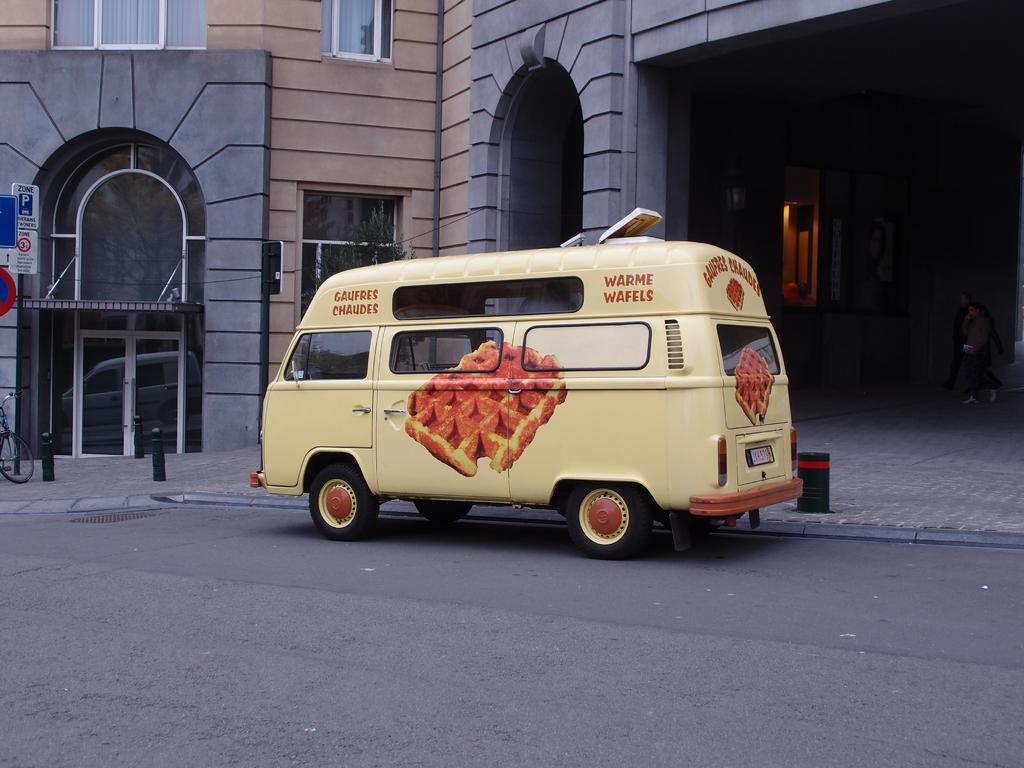Can you describe this image briefly? In this picture I can see a van on the road and I can see building and couple of boards with some text and I can see bicycle on the sidewalk. 